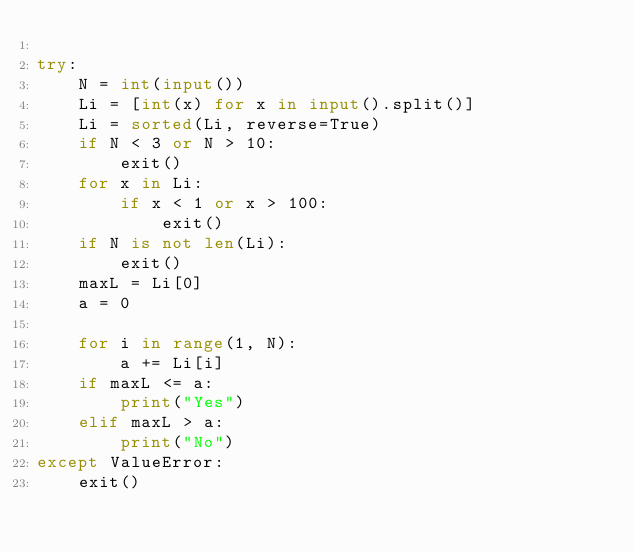Convert code to text. <code><loc_0><loc_0><loc_500><loc_500><_Python_>
try:
    N = int(input())
    Li = [int(x) for x in input().split()]
    Li = sorted(Li, reverse=True)
    if N < 3 or N > 10:
        exit()
    for x in Li:
        if x < 1 or x > 100:
            exit()
    if N is not len(Li):
        exit()
    maxL = Li[0]
    a = 0

    for i in range(1, N):
        a += Li[i]
    if maxL <= a:
        print("Yes")
    elif maxL > a:
        print("No")
except ValueError:
    exit()

</code> 